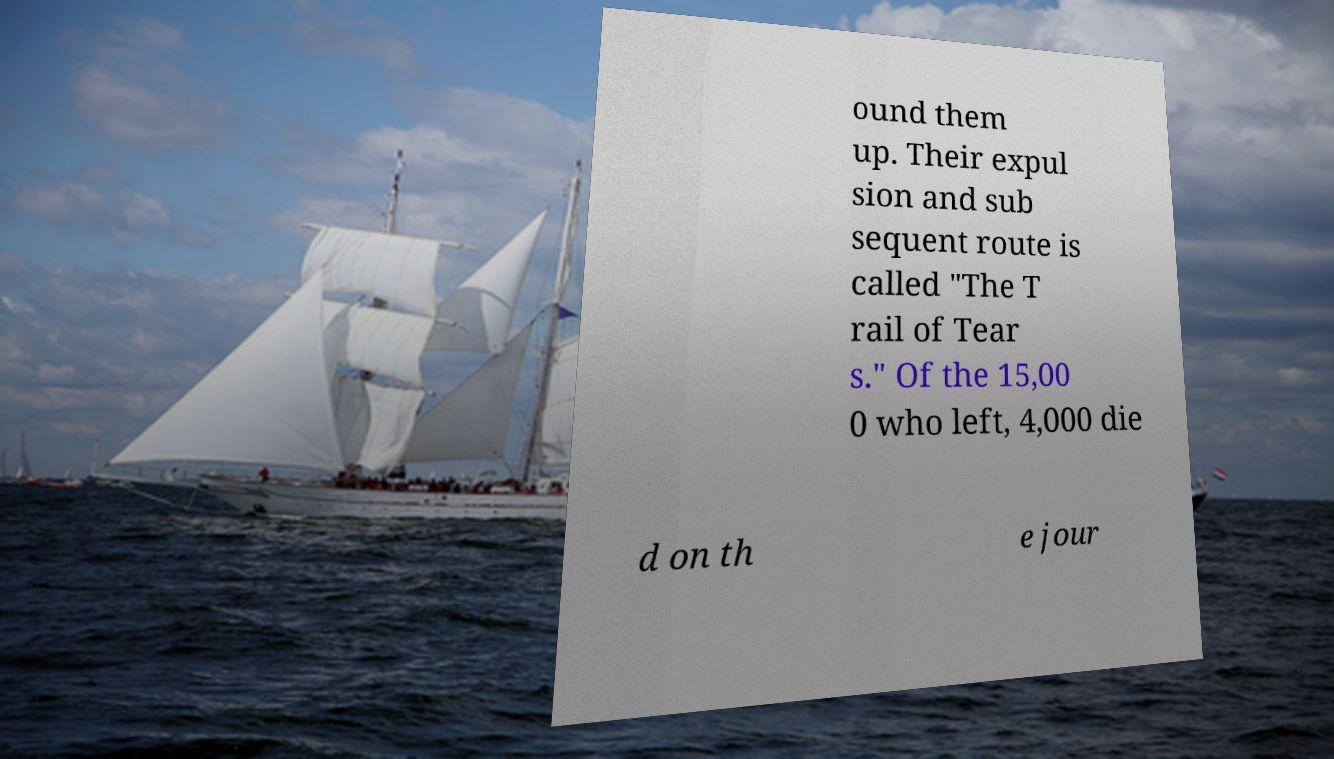Can you accurately transcribe the text from the provided image for me? ound them up. Their expul sion and sub sequent route is called "The T rail of Tear s." Of the 15,00 0 who left, 4,000 die d on th e jour 